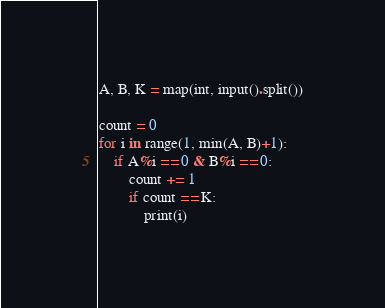Convert code to text. <code><loc_0><loc_0><loc_500><loc_500><_Python_>A, B, K = map(int, input().split())

count = 0
for i in range(1, min(A, B)+1):
    if A%i == 0 & B%i == 0:
        count += 1
        if count == K:
            print(i)
</code> 